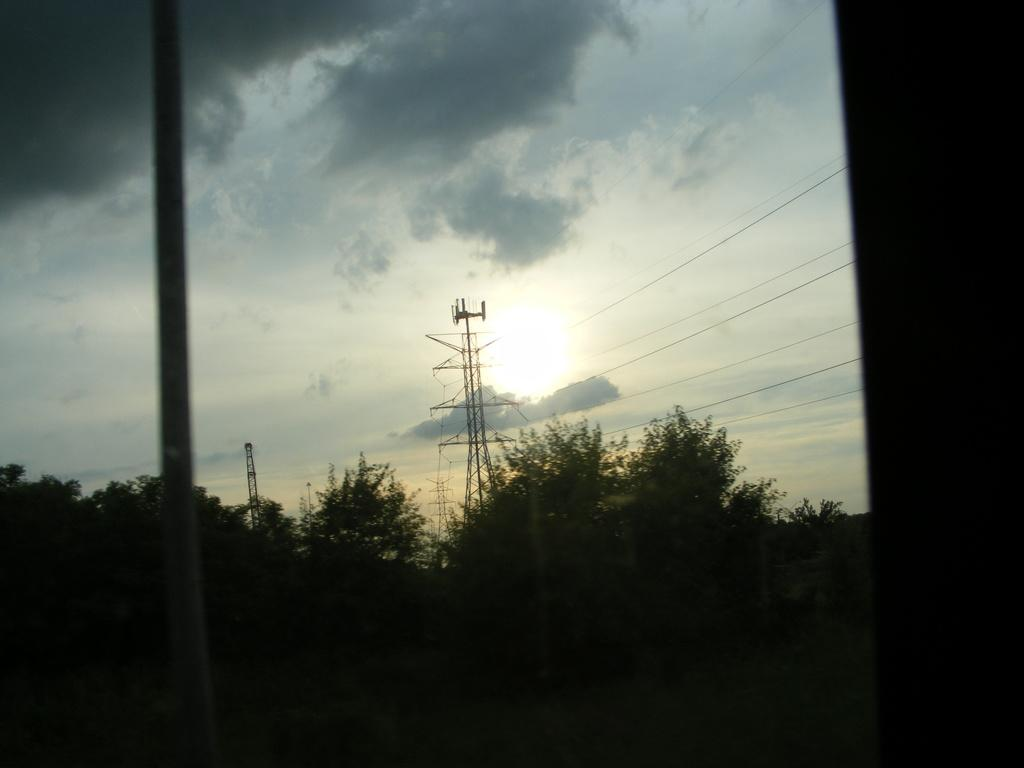What type of natural elements can be seen in the image? There are trees in the image. What man-made structure is present in the image? There is a pole in the image. What type of infrastructure can be seen in the image? There are towers with wires in the image. What is visible in the background of the image? The sky is visible in the background of the image. What weather conditions can be inferred from the image? The presence of clouds and the visible sun suggest it is partly cloudy. What type of lipstick is being used by the apparatus in the image? There is no apparatus or lipstick present in the image. What type of voyage is depicted in the image? There is no voyage depicted in the image; it features trees, a pole, towers with wires, and a sky with clouds and the sun. 